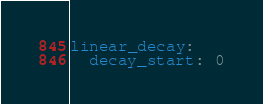<code> <loc_0><loc_0><loc_500><loc_500><_YAML_>linear_decay:
  decay_start: 0
</code> 